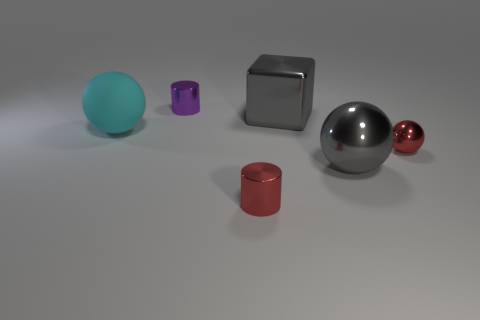Is there any other thing that is the same material as the large cyan sphere?
Your response must be concise. No. Is the color of the cube the same as the large metallic ball?
Keep it short and to the point. Yes. How many things are gray blocks or tiny cylinders that are behind the red shiny cylinder?
Keep it short and to the point. 2. What number of other objects are there of the same size as the purple metallic cylinder?
Your answer should be very brief. 2. Is the material of the large gray object that is behind the big matte thing the same as the red thing in front of the tiny sphere?
Make the answer very short. Yes. There is a gray metal sphere; how many tiny metal spheres are left of it?
Provide a short and direct response. 0. What number of cyan objects are either cubes or small spheres?
Provide a short and direct response. 0. There is a cyan thing that is the same size as the metallic cube; what is its material?
Your answer should be very brief. Rubber. The shiny thing that is behind the gray metallic sphere and right of the shiny cube has what shape?
Keep it short and to the point. Sphere. What color is the metallic sphere that is the same size as the cube?
Offer a very short reply. Gray. 